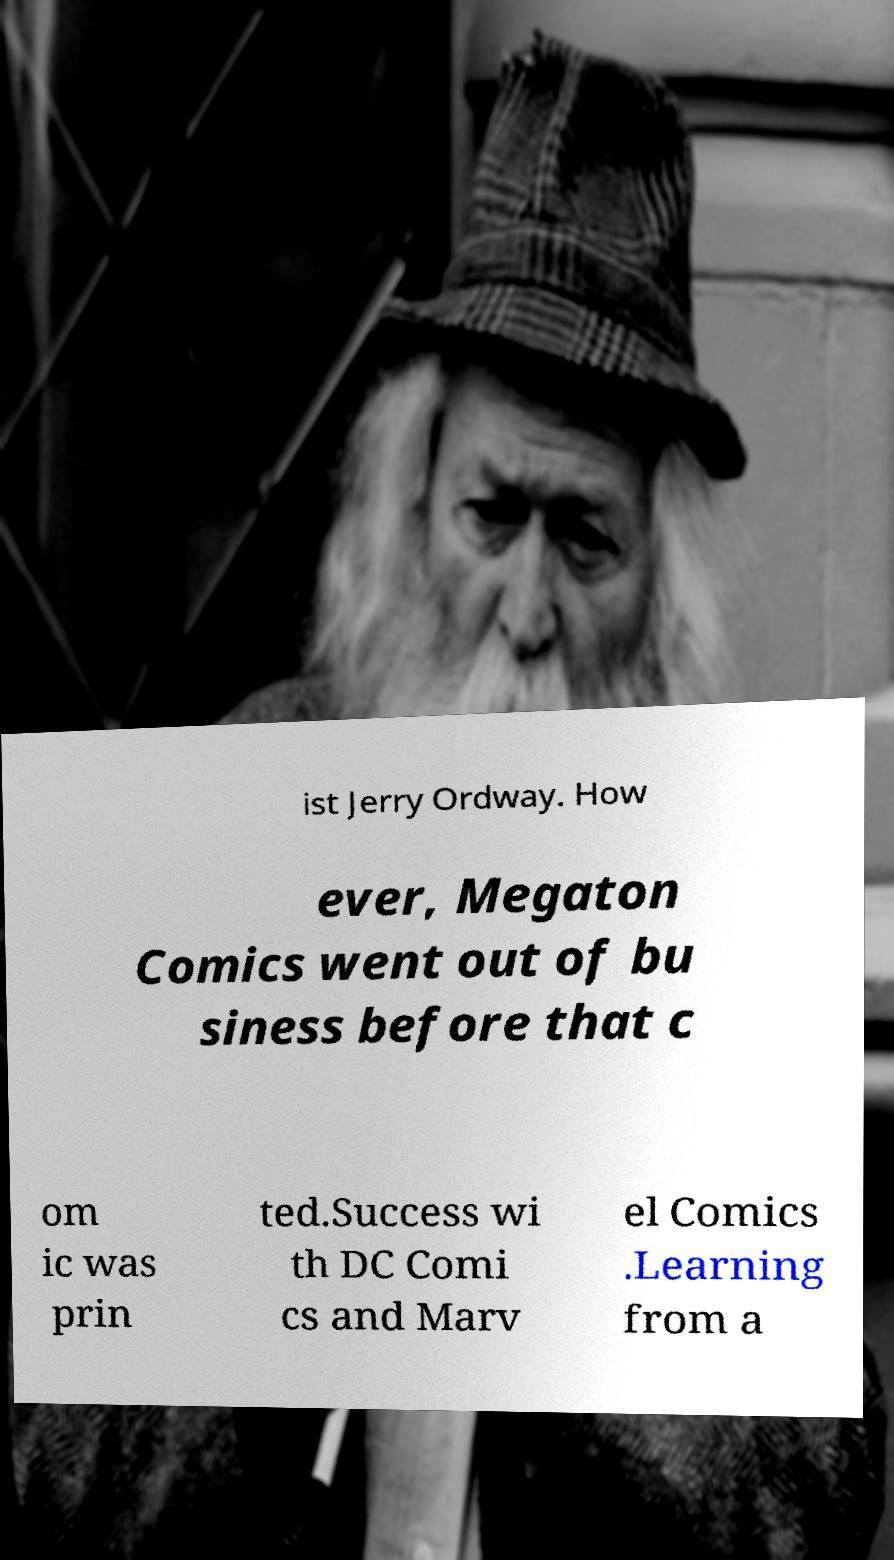For documentation purposes, I need the text within this image transcribed. Could you provide that? ist Jerry Ordway. How ever, Megaton Comics went out of bu siness before that c om ic was prin ted.Success wi th DC Comi cs and Marv el Comics .Learning from a 